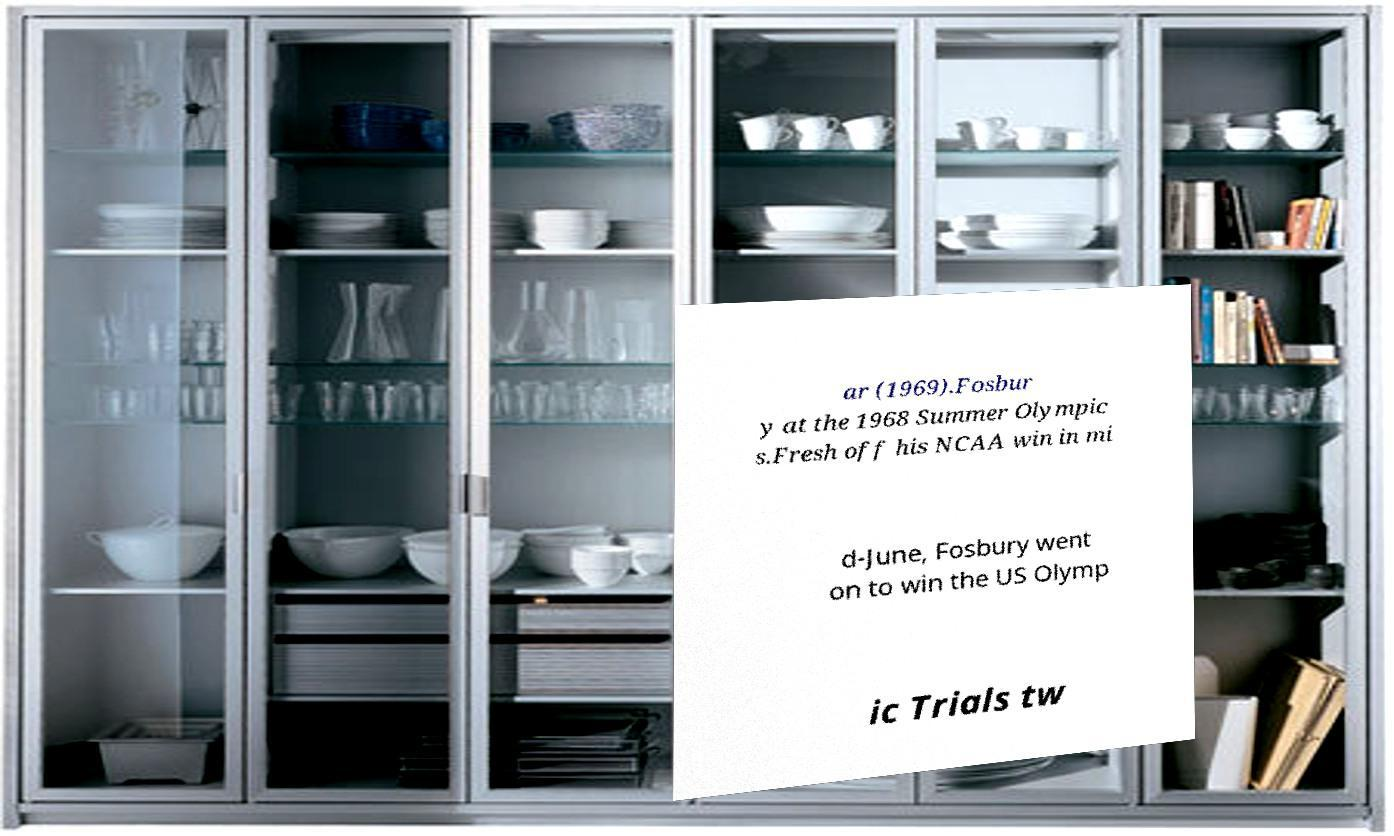For documentation purposes, I need the text within this image transcribed. Could you provide that? ar (1969).Fosbur y at the 1968 Summer Olympic s.Fresh off his NCAA win in mi d-June, Fosbury went on to win the US Olymp ic Trials tw 